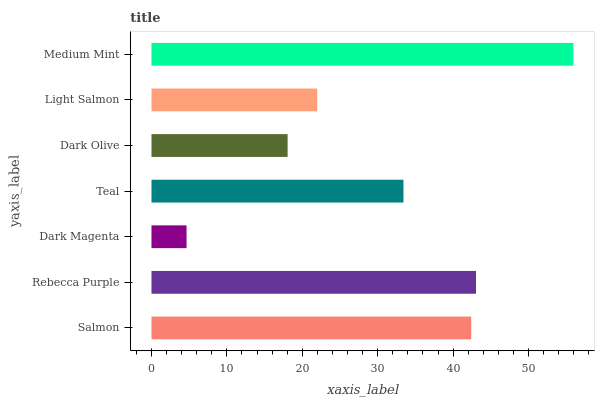Is Dark Magenta the minimum?
Answer yes or no. Yes. Is Medium Mint the maximum?
Answer yes or no. Yes. Is Rebecca Purple the minimum?
Answer yes or no. No. Is Rebecca Purple the maximum?
Answer yes or no. No. Is Rebecca Purple greater than Salmon?
Answer yes or no. Yes. Is Salmon less than Rebecca Purple?
Answer yes or no. Yes. Is Salmon greater than Rebecca Purple?
Answer yes or no. No. Is Rebecca Purple less than Salmon?
Answer yes or no. No. Is Teal the high median?
Answer yes or no. Yes. Is Teal the low median?
Answer yes or no. Yes. Is Medium Mint the high median?
Answer yes or no. No. Is Dark Olive the low median?
Answer yes or no. No. 